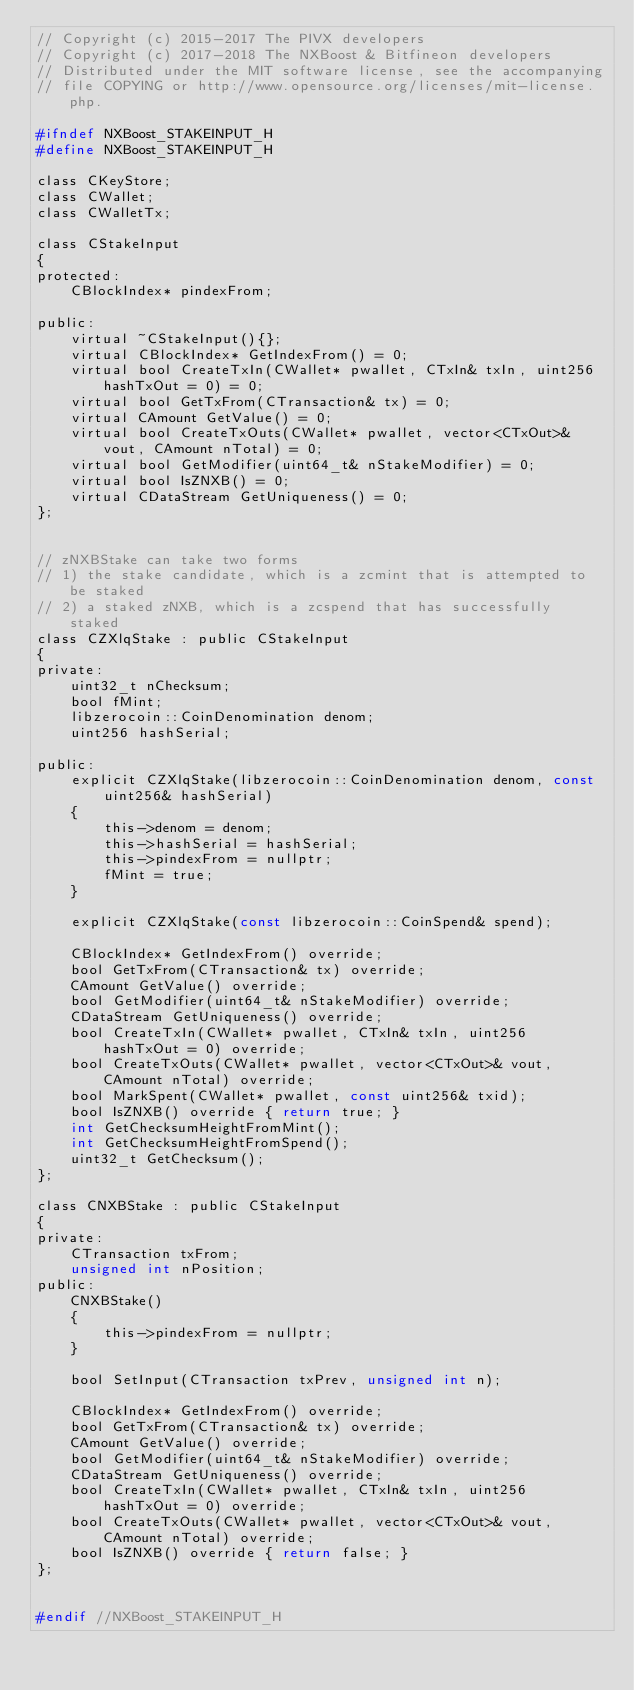<code> <loc_0><loc_0><loc_500><loc_500><_C_>// Copyright (c) 2015-2017 The PIVX developers// Copyright (c) 2017-2018 The NXBoost & Bitfineon developers
// Distributed under the MIT software license, see the accompanying
// file COPYING or http://www.opensource.org/licenses/mit-license.php.

#ifndef NXBoost_STAKEINPUT_H
#define NXBoost_STAKEINPUT_H

class CKeyStore;
class CWallet;
class CWalletTx;

class CStakeInput
{
protected:
    CBlockIndex* pindexFrom;

public:
    virtual ~CStakeInput(){};
    virtual CBlockIndex* GetIndexFrom() = 0;
    virtual bool CreateTxIn(CWallet* pwallet, CTxIn& txIn, uint256 hashTxOut = 0) = 0;
    virtual bool GetTxFrom(CTransaction& tx) = 0;
    virtual CAmount GetValue() = 0;
    virtual bool CreateTxOuts(CWallet* pwallet, vector<CTxOut>& vout, CAmount nTotal) = 0;
    virtual bool GetModifier(uint64_t& nStakeModifier) = 0;
    virtual bool IsZNXB() = 0;
    virtual CDataStream GetUniqueness() = 0;
};


// zNXBStake can take two forms
// 1) the stake candidate, which is a zcmint that is attempted to be staked
// 2) a staked zNXB, which is a zcspend that has successfully staked
class CZXlqStake : public CStakeInput
{
private:
    uint32_t nChecksum;
    bool fMint;
    libzerocoin::CoinDenomination denom;
    uint256 hashSerial;

public:
    explicit CZXlqStake(libzerocoin::CoinDenomination denom, const uint256& hashSerial)
    {
        this->denom = denom;
        this->hashSerial = hashSerial;
        this->pindexFrom = nullptr;
        fMint = true;
    }

    explicit CZXlqStake(const libzerocoin::CoinSpend& spend);

    CBlockIndex* GetIndexFrom() override;
    bool GetTxFrom(CTransaction& tx) override;
    CAmount GetValue() override;
    bool GetModifier(uint64_t& nStakeModifier) override;
    CDataStream GetUniqueness() override;
    bool CreateTxIn(CWallet* pwallet, CTxIn& txIn, uint256 hashTxOut = 0) override;
    bool CreateTxOuts(CWallet* pwallet, vector<CTxOut>& vout, CAmount nTotal) override;
    bool MarkSpent(CWallet* pwallet, const uint256& txid);
    bool IsZNXB() override { return true; }
    int GetChecksumHeightFromMint();
    int GetChecksumHeightFromSpend();
    uint32_t GetChecksum();
};

class CNXBStake : public CStakeInput
{
private:
    CTransaction txFrom;
    unsigned int nPosition;
public:
    CNXBStake()
    {
        this->pindexFrom = nullptr;
    }

    bool SetInput(CTransaction txPrev, unsigned int n);

    CBlockIndex* GetIndexFrom() override;
    bool GetTxFrom(CTransaction& tx) override;
    CAmount GetValue() override;
    bool GetModifier(uint64_t& nStakeModifier) override;
    CDataStream GetUniqueness() override;
    bool CreateTxIn(CWallet* pwallet, CTxIn& txIn, uint256 hashTxOut = 0) override;
    bool CreateTxOuts(CWallet* pwallet, vector<CTxOut>& vout, CAmount nTotal) override;
    bool IsZNXB() override { return false; }
};


#endif //NXBoost_STAKEINPUT_H
</code> 